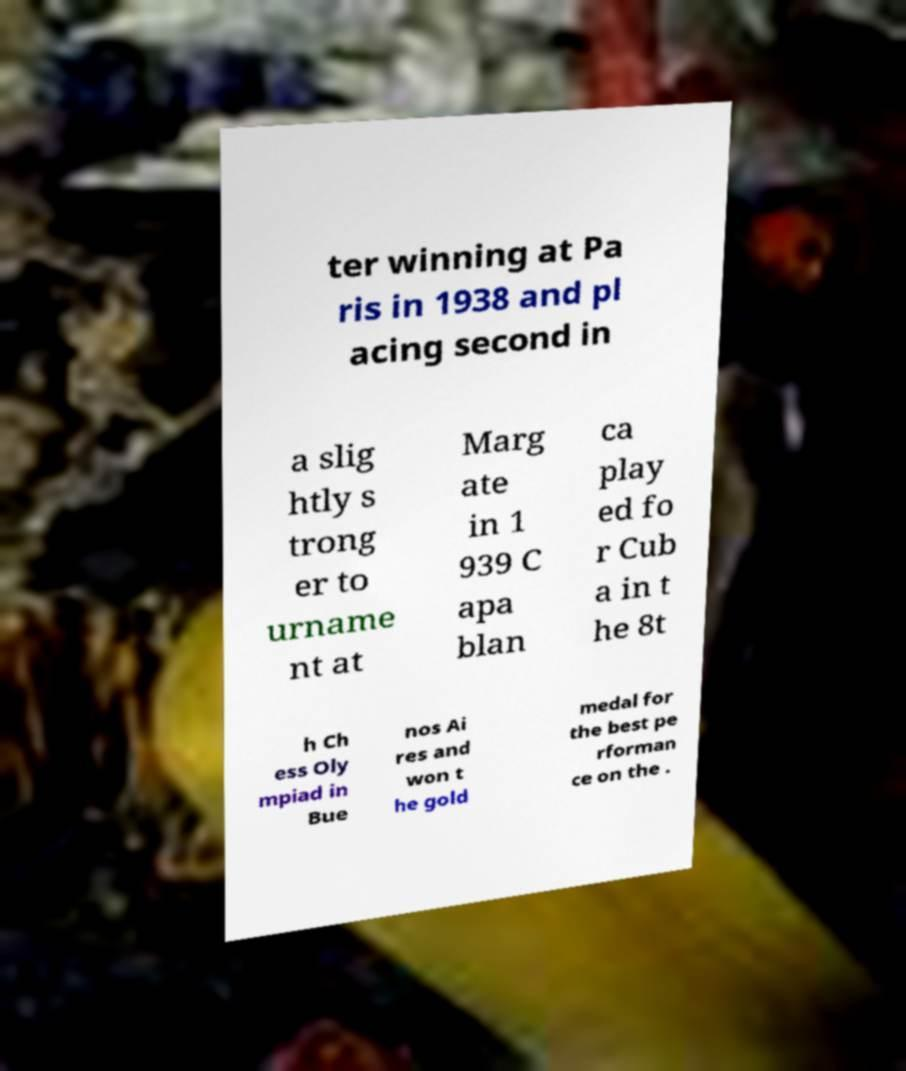Could you extract and type out the text from this image? ter winning at Pa ris in 1938 and pl acing second in a slig htly s trong er to urname nt at Marg ate in 1 939 C apa blan ca play ed fo r Cub a in t he 8t h Ch ess Oly mpiad in Bue nos Ai res and won t he gold medal for the best pe rforman ce on the . 